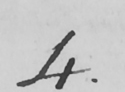Please transcribe the handwritten text in this image. 4 . 